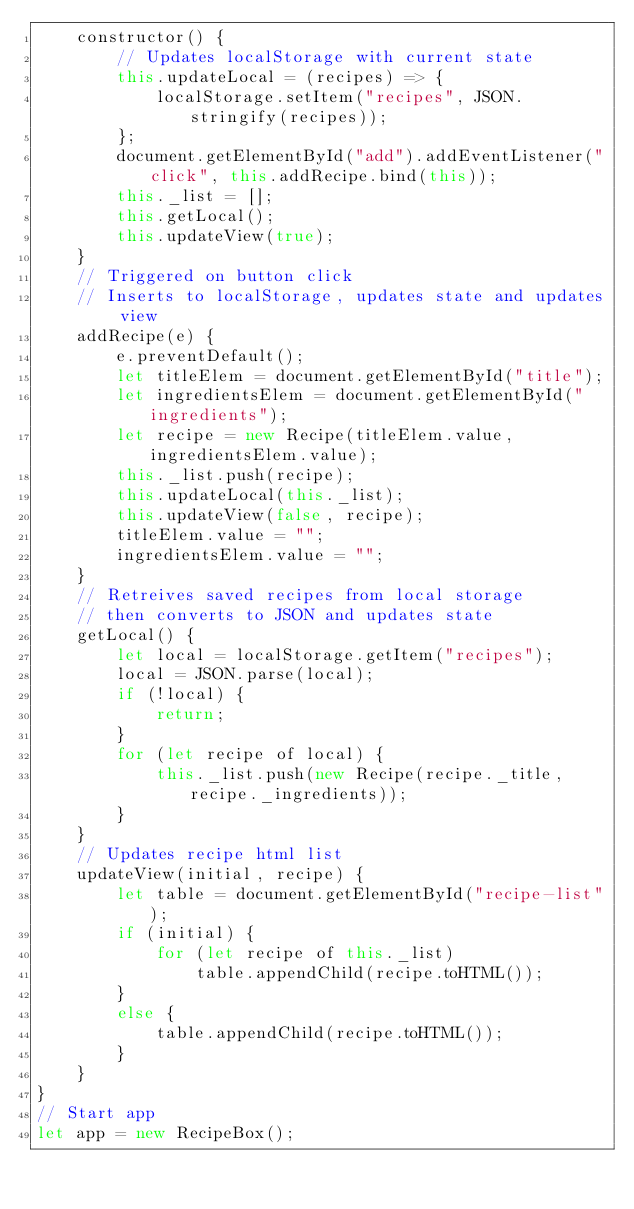Convert code to text. <code><loc_0><loc_0><loc_500><loc_500><_JavaScript_>    constructor() {
        // Updates localStorage with current state
        this.updateLocal = (recipes) => {
            localStorage.setItem("recipes", JSON.stringify(recipes));
        };
        document.getElementById("add").addEventListener("click", this.addRecipe.bind(this));
        this._list = [];
        this.getLocal();
        this.updateView(true);
    }
    // Triggered on button click
    // Inserts to localStorage, updates state and updates view
    addRecipe(e) {
        e.preventDefault();
        let titleElem = document.getElementById("title");
        let ingredientsElem = document.getElementById("ingredients");
        let recipe = new Recipe(titleElem.value, ingredientsElem.value);
        this._list.push(recipe);
        this.updateLocal(this._list);
        this.updateView(false, recipe);
        titleElem.value = "";
        ingredientsElem.value = "";
    }
    // Retreives saved recipes from local storage
    // then converts to JSON and updates state
    getLocal() {
        let local = localStorage.getItem("recipes");
        local = JSON.parse(local);
        if (!local) {
            return;
        }
        for (let recipe of local) {
            this._list.push(new Recipe(recipe._title, recipe._ingredients));
        }
    }
    // Updates recipe html list
    updateView(initial, recipe) {
        let table = document.getElementById("recipe-list");
        if (initial) {
            for (let recipe of this._list)
                table.appendChild(recipe.toHTML());
        }
        else {
            table.appendChild(recipe.toHTML());
        }
    }
}
// Start app
let app = new RecipeBox();</code> 